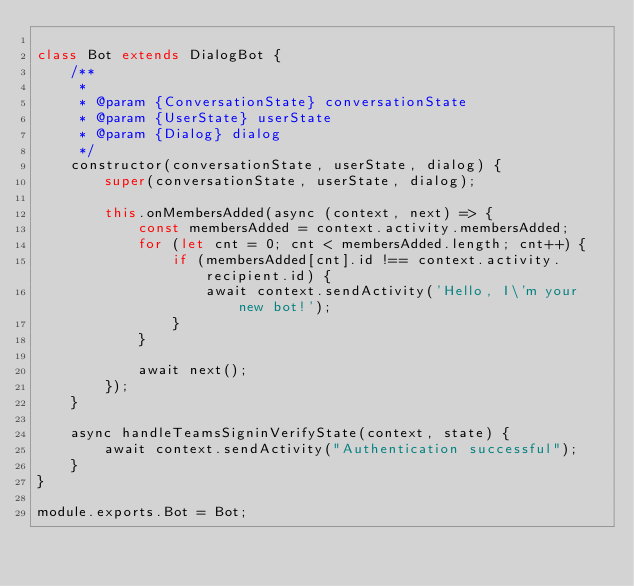<code> <loc_0><loc_0><loc_500><loc_500><_JavaScript_>
class Bot extends DialogBot {
    /**
     *
     * @param {ConversationState} conversationState
     * @param {UserState} userState
     * @param {Dialog} dialog
     */
    constructor(conversationState, userState, dialog) {
        super(conversationState, userState, dialog);

        this.onMembersAdded(async (context, next) => {
            const membersAdded = context.activity.membersAdded;
            for (let cnt = 0; cnt < membersAdded.length; cnt++) {
                if (membersAdded[cnt].id !== context.activity.recipient.id) {
                    await context.sendActivity('Hello, I\'m your new bot!');
                }
            }

            await next();
        });
    }

    async handleTeamsSigninVerifyState(context, state) {
        await context.sendActivity("Authentication successful");
    }
}

module.exports.Bot = Bot;</code> 